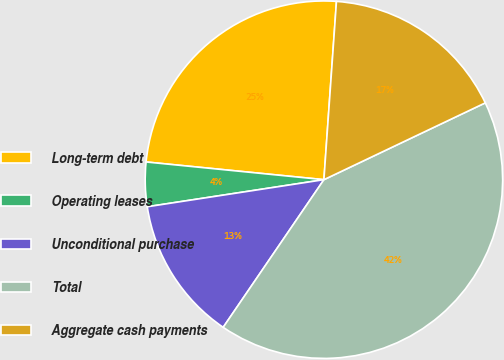<chart> <loc_0><loc_0><loc_500><loc_500><pie_chart><fcel>Long-term debt<fcel>Operating leases<fcel>Unconditional purchase<fcel>Total<fcel>Aggregate cash payments<nl><fcel>24.54%<fcel>4.0%<fcel>13.05%<fcel>41.6%<fcel>16.81%<nl></chart> 